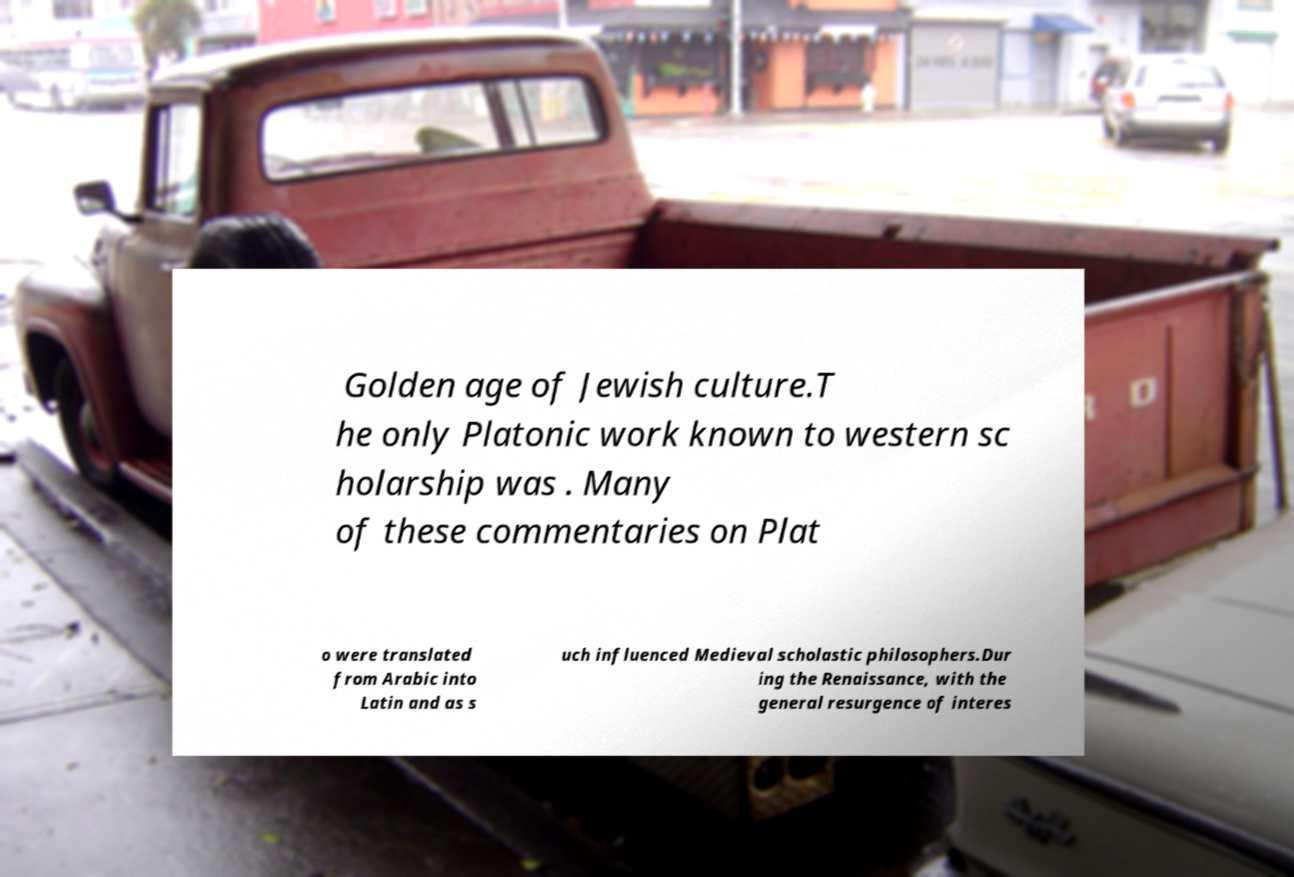What messages or text are displayed in this image? I need them in a readable, typed format. Golden age of Jewish culture.T he only Platonic work known to western sc holarship was . Many of these commentaries on Plat o were translated from Arabic into Latin and as s uch influenced Medieval scholastic philosophers.Dur ing the Renaissance, with the general resurgence of interes 